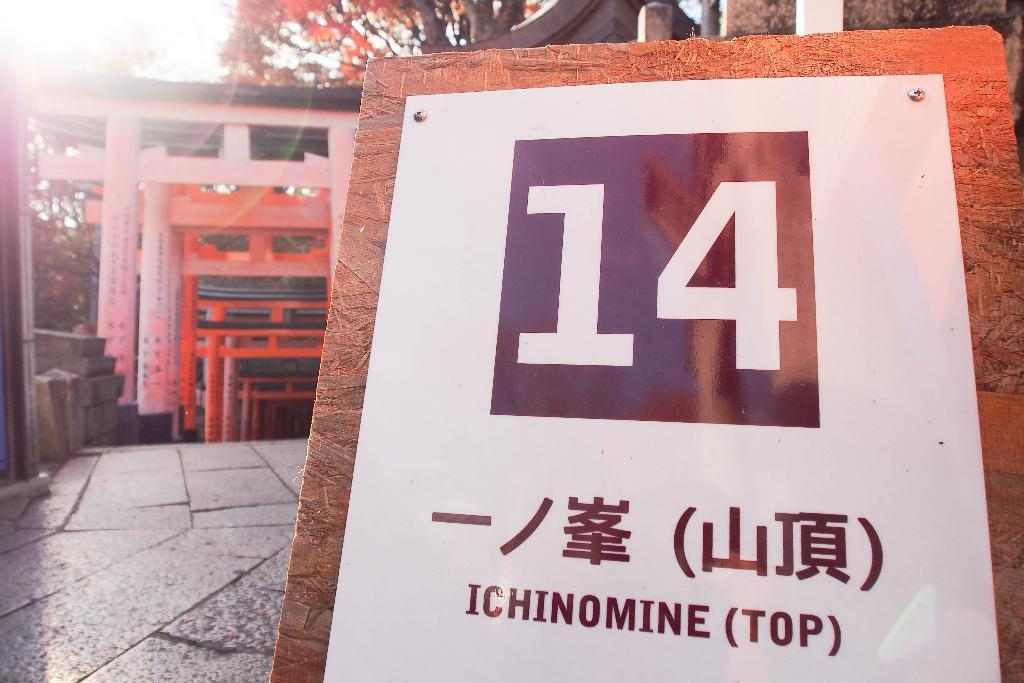What is written or drawn on the whiteboard in the image? There is something written on a whiteboard in the image, but we cannot determine the content from the image alone. What can be seen in the background of the image? There are trees, arches, and the ground visible in the background of the image. How many toes can be seen on the person standing near the arches in the image? There is no person visible in the image, so we cannot determine the number of toes present. 